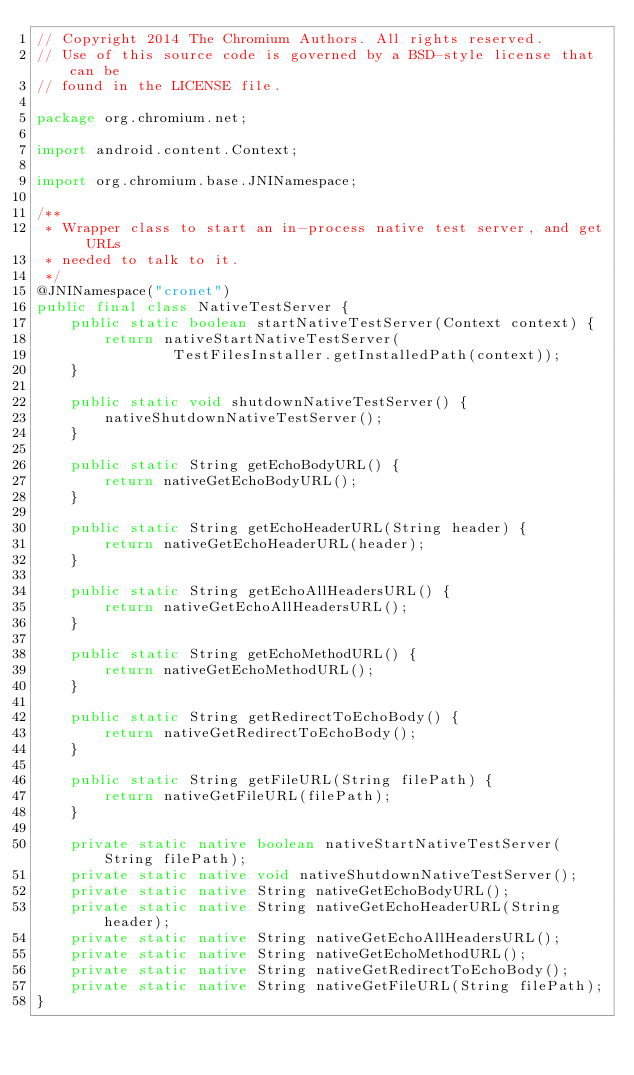Convert code to text. <code><loc_0><loc_0><loc_500><loc_500><_Java_>// Copyright 2014 The Chromium Authors. All rights reserved.
// Use of this source code is governed by a BSD-style license that can be
// found in the LICENSE file.

package org.chromium.net;

import android.content.Context;

import org.chromium.base.JNINamespace;

/**
 * Wrapper class to start an in-process native test server, and get URLs
 * needed to talk to it.
 */
@JNINamespace("cronet")
public final class NativeTestServer {
    public static boolean startNativeTestServer(Context context) {
        return nativeStartNativeTestServer(
                TestFilesInstaller.getInstalledPath(context));
    }

    public static void shutdownNativeTestServer() {
        nativeShutdownNativeTestServer();
    }

    public static String getEchoBodyURL() {
        return nativeGetEchoBodyURL();
    }

    public static String getEchoHeaderURL(String header) {
        return nativeGetEchoHeaderURL(header);
    }

    public static String getEchoAllHeadersURL() {
        return nativeGetEchoAllHeadersURL();
    }

    public static String getEchoMethodURL() {
        return nativeGetEchoMethodURL();
    }

    public static String getRedirectToEchoBody() {
        return nativeGetRedirectToEchoBody();
    }

    public static String getFileURL(String filePath) {
        return nativeGetFileURL(filePath);
    }

    private static native boolean nativeStartNativeTestServer(String filePath);
    private static native void nativeShutdownNativeTestServer();
    private static native String nativeGetEchoBodyURL();
    private static native String nativeGetEchoHeaderURL(String header);
    private static native String nativeGetEchoAllHeadersURL();
    private static native String nativeGetEchoMethodURL();
    private static native String nativeGetRedirectToEchoBody();
    private static native String nativeGetFileURL(String filePath);
}
</code> 